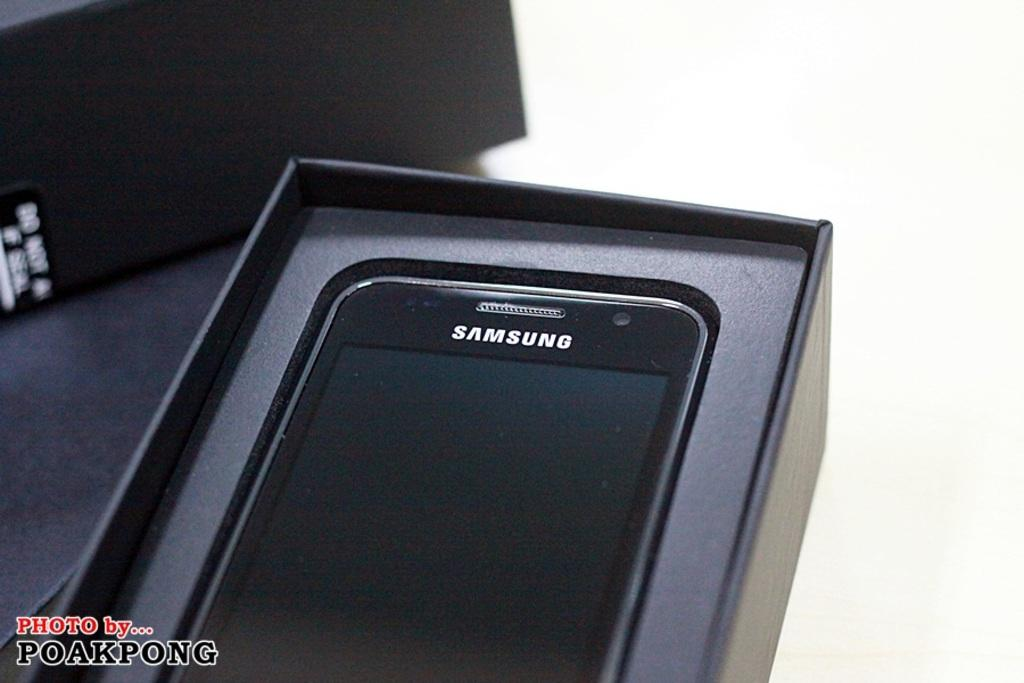<image>
Provide a brief description of the given image. a samsung phone still in the box, photo by poakpong 